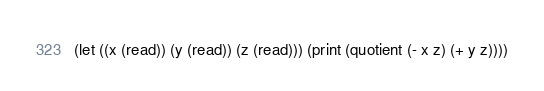Convert code to text. <code><loc_0><loc_0><loc_500><loc_500><_Scheme_>(let ((x (read)) (y (read)) (z (read))) (print (quotient (- x z) (+ y z))))</code> 